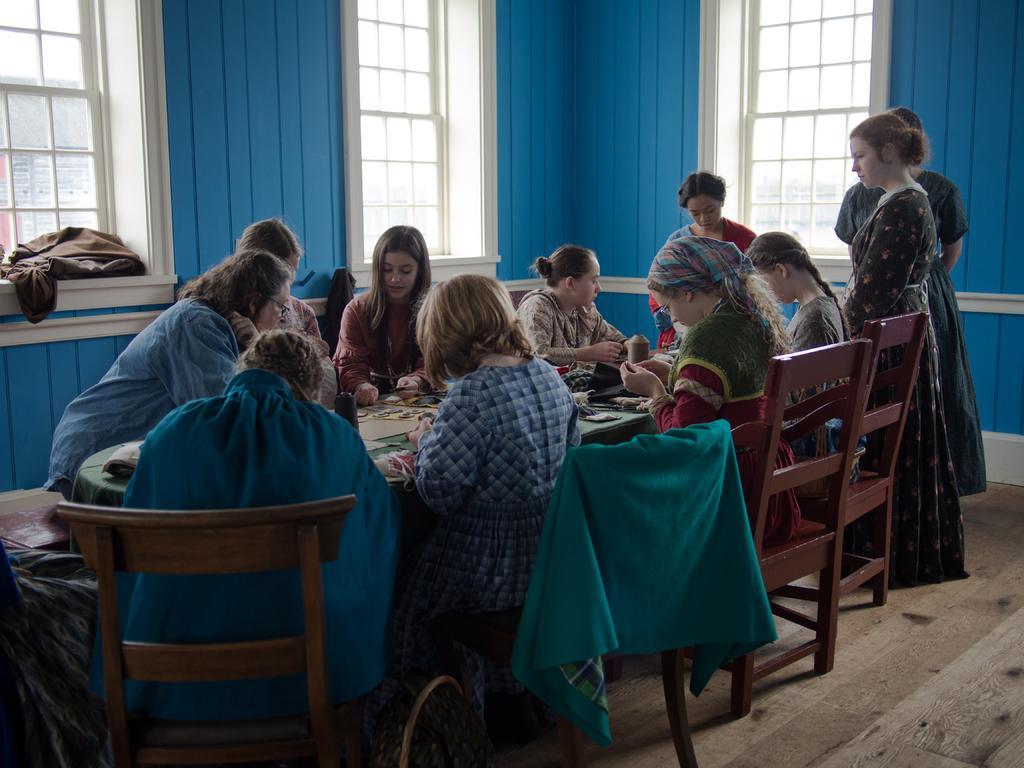Describe this image in one or two sentences. Persons are sitting on the chair and on the table we have paper and in the back there are windows made of glass. 